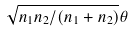<formula> <loc_0><loc_0><loc_500><loc_500>\sqrt { n _ { 1 } n _ { 2 } / ( n _ { 1 } + n _ { 2 } ) } \theta</formula> 